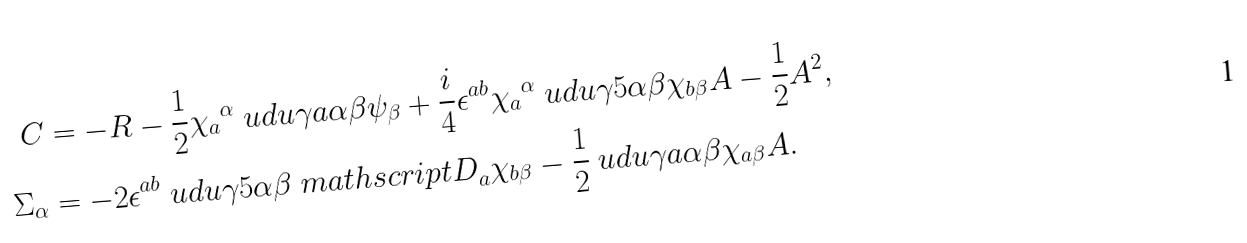Convert formula to latex. <formula><loc_0><loc_0><loc_500><loc_500>C & = - R - \frac { 1 } { 2 } { \chi _ { a } } ^ { \alpha } \ u d u \gamma { a } \alpha \beta \psi _ { \beta } + \frac { i } { 4 } \epsilon ^ { a b } { \chi _ { a } } ^ { \alpha } \ u d u \gamma 5 \alpha \beta \chi _ { b \beta } A - \frac { 1 } { 2 } A ^ { 2 } , \\ \Sigma _ { \alpha } & = - 2 \epsilon ^ { a b } \ u d u \gamma 5 \alpha \beta { \ m a t h s c r i p t { D } } _ { a } \chi _ { b \beta } - \frac { 1 } { 2 } \ u d u \gamma { a } \alpha \beta \chi _ { a \beta } A .</formula> 